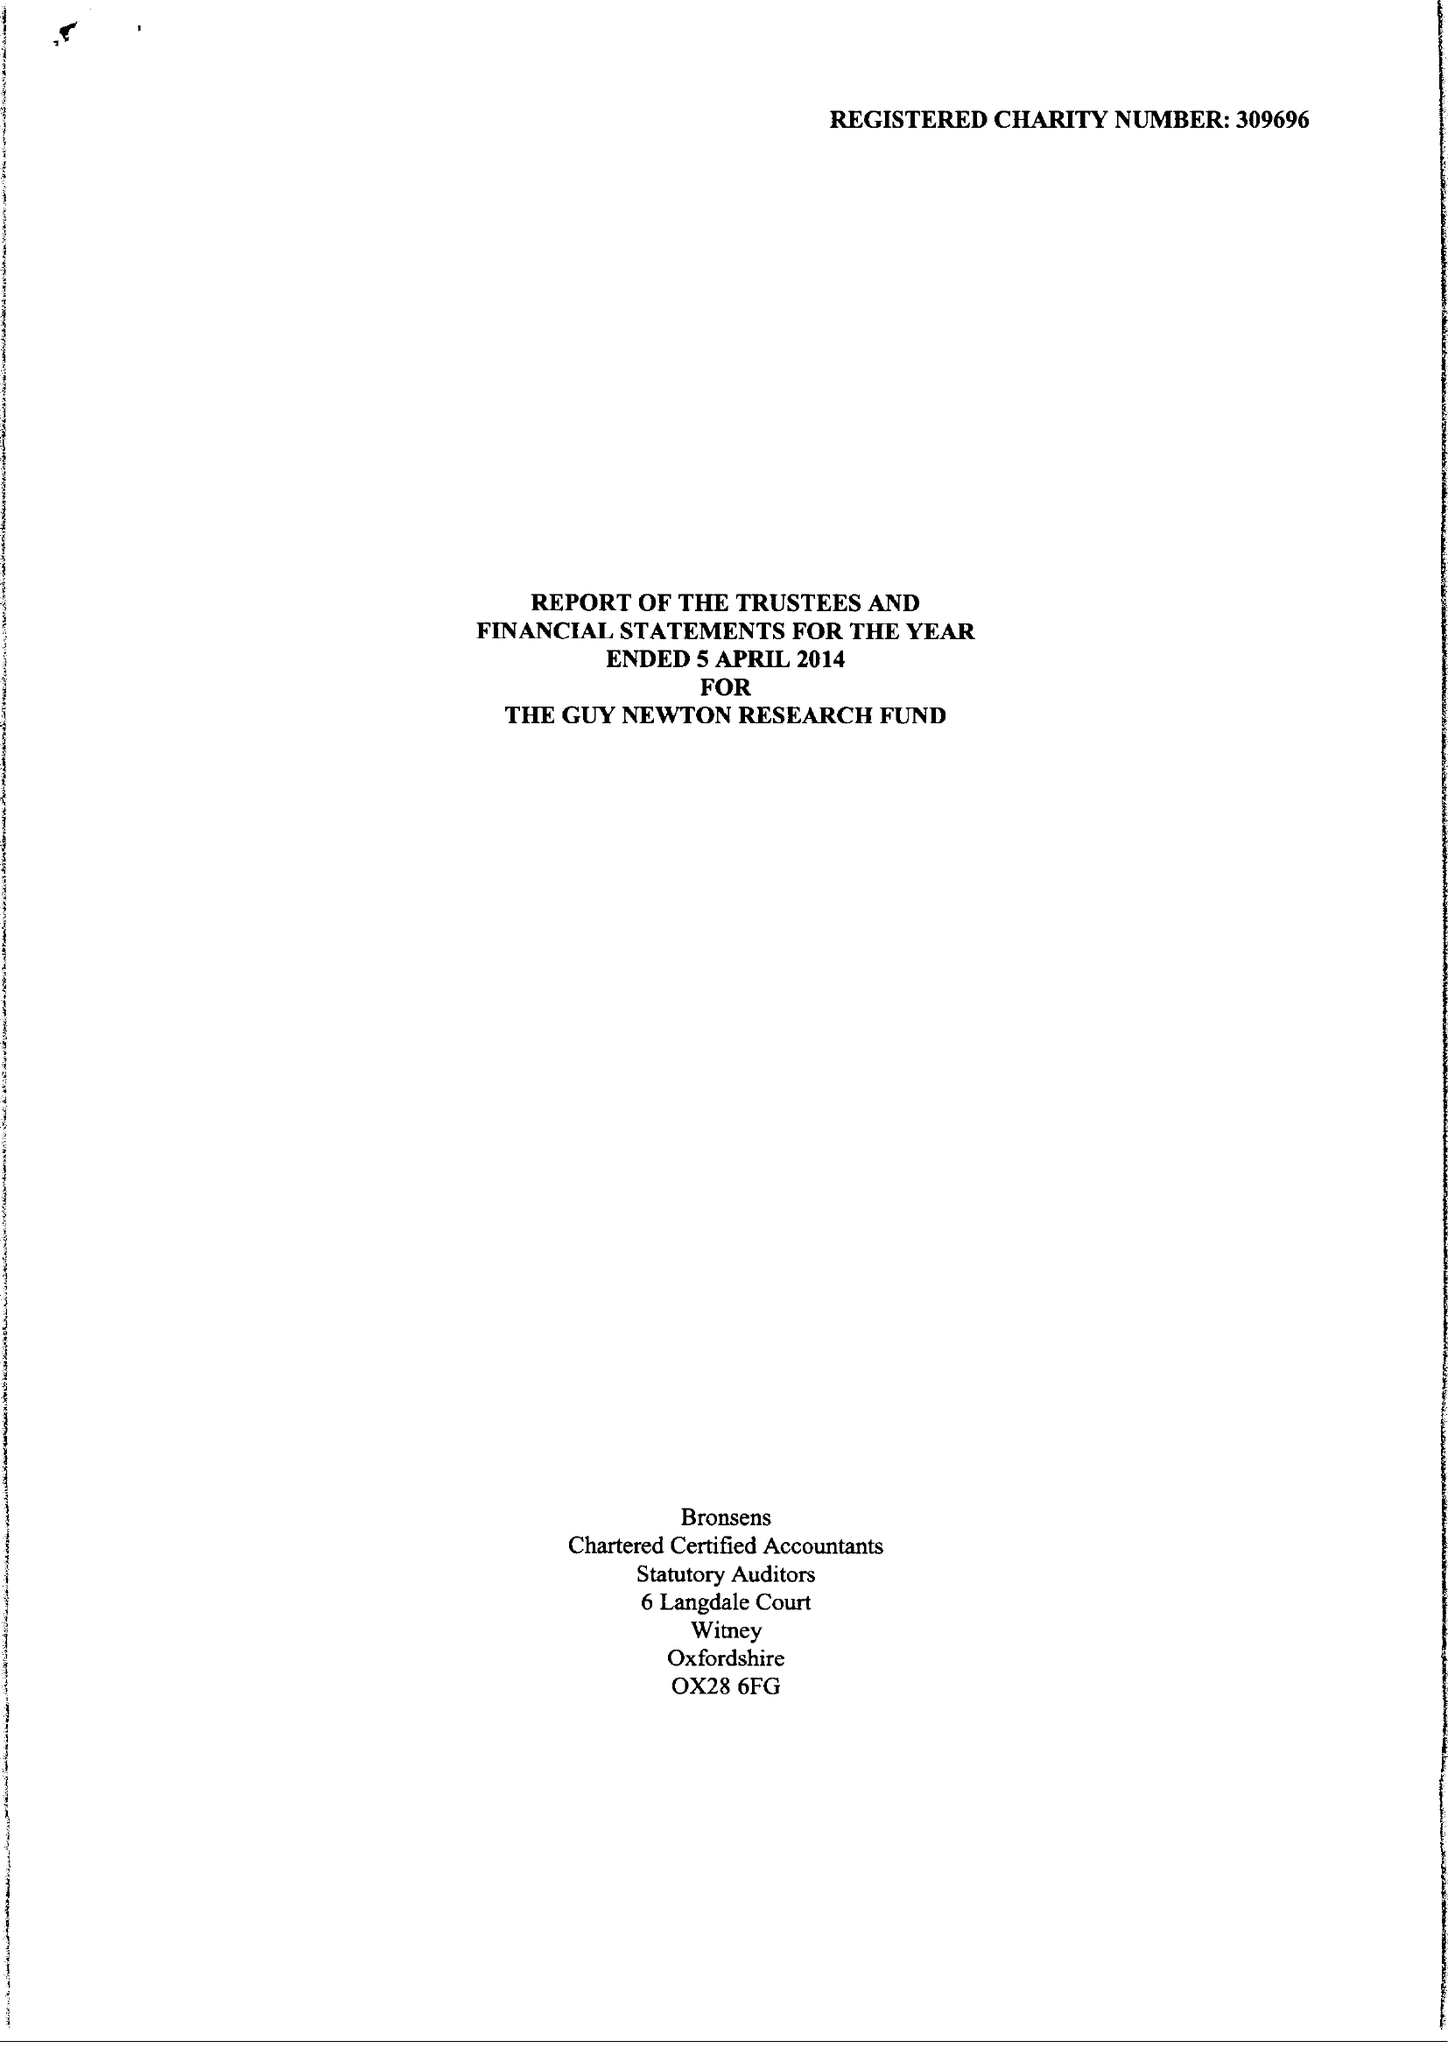What is the value for the address__postcode?
Answer the question using a single word or phrase. OX1 3RE 